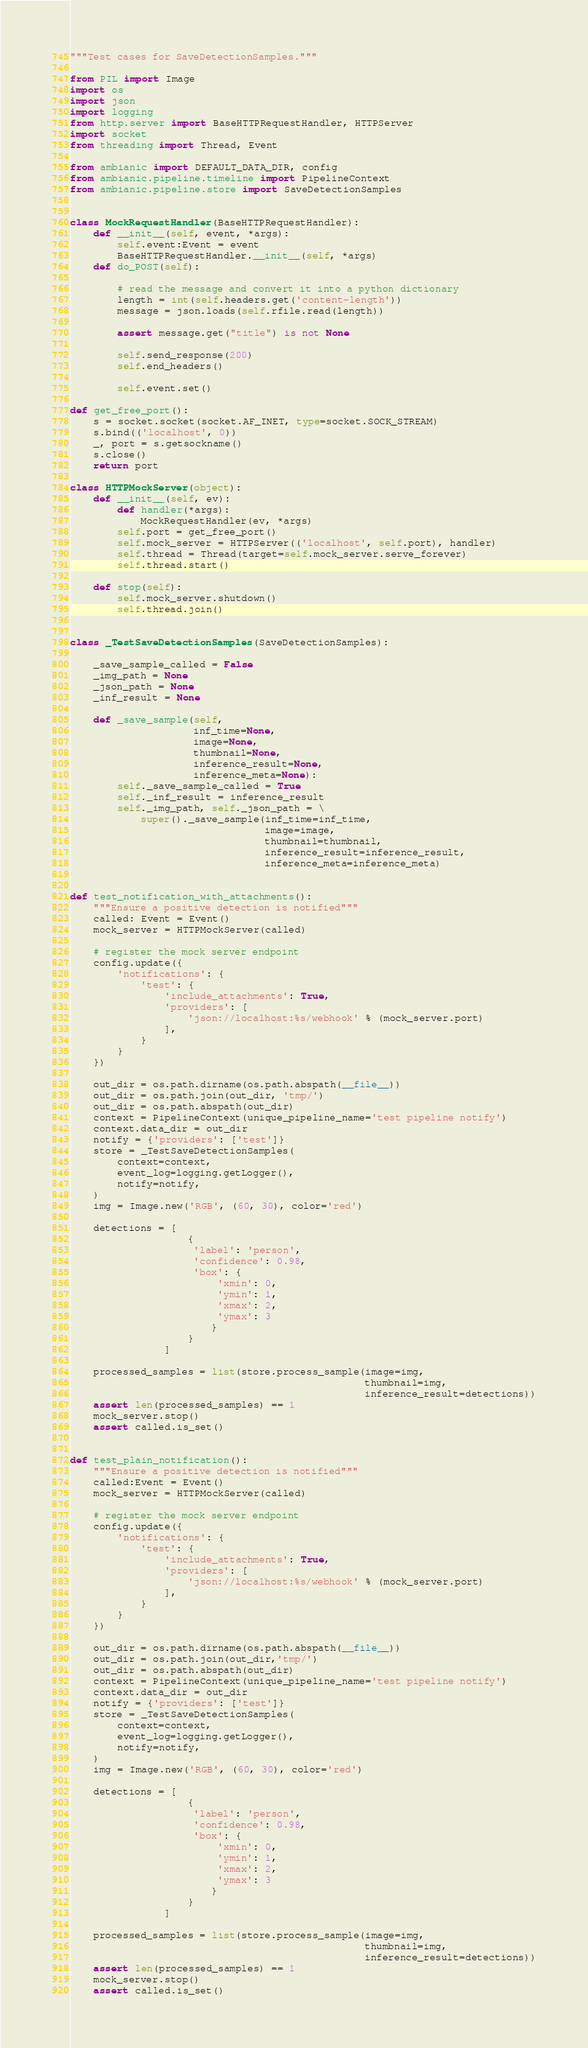<code> <loc_0><loc_0><loc_500><loc_500><_Python_>"""Test cases for SaveDetectionSamples."""

from PIL import Image
import os
import json
import logging
from http.server import BaseHTTPRequestHandler, HTTPServer
import socket
from threading import Thread, Event

from ambianic import DEFAULT_DATA_DIR, config
from ambianic.pipeline.timeline import PipelineContext
from ambianic.pipeline.store import SaveDetectionSamples


class MockRequestHandler(BaseHTTPRequestHandler):
    def __init__(self, event, *args):
        self.event:Event = event
        BaseHTTPRequestHandler.__init__(self, *args)
    def do_POST(self):

        # read the message and convert it into a python dictionary
        length = int(self.headers.get('content-length'))
        message = json.loads(self.rfile.read(length))

        assert message.get("title") is not None

        self.send_response(200)
        self.end_headers()

        self.event.set()

def get_free_port():
    s = socket.socket(socket.AF_INET, type=socket.SOCK_STREAM)
    s.bind(('localhost', 0))
    _, port = s.getsockname()
    s.close()
    return port

class HTTPMockServer(object):
    def __init__(self, ev):
        def handler(*args):
            MockRequestHandler(ev, *args)
        self.port = get_free_port()
        self.mock_server = HTTPServer(('localhost', self.port), handler)
        self.thread = Thread(target=self.mock_server.serve_forever)
        self.thread.start()
    
    def stop(self):
        self.mock_server.shutdown()
        self.thread.join()


class _TestSaveDetectionSamples(SaveDetectionSamples):

    _save_sample_called = False
    _img_path = None
    _json_path = None
    _inf_result = None

    def _save_sample(self,
                     inf_time=None,
                     image=None,
                     thumbnail=None,
                     inference_result=None,
                     inference_meta=None):
        self._save_sample_called = True
        self._inf_result = inference_result
        self._img_path, self._json_path = \
            super()._save_sample(inf_time=inf_time,
                                 image=image,
                                 thumbnail=thumbnail,
                                 inference_result=inference_result,
                                 inference_meta=inference_meta)


def test_notification_with_attachments():
    """Ensure a positive detection is notified"""
    called: Event = Event()
    mock_server = HTTPMockServer(called)

    # register the mock server endpoint
    config.update({
        'notifications': {
            'test': {
                'include_attachments': True,
                'providers': [
                    'json://localhost:%s/webhook' % (mock_server.port)
                ],
            }
        }
    })

    out_dir = os.path.dirname(os.path.abspath(__file__))
    out_dir = os.path.join(out_dir, 'tmp/')
    out_dir = os.path.abspath(out_dir)
    context = PipelineContext(unique_pipeline_name='test pipeline notify')
    context.data_dir = out_dir
    notify = {'providers': ['test']}
    store = _TestSaveDetectionSamples(
        context=context,
        event_log=logging.getLogger(),
        notify=notify,
    )
    img = Image.new('RGB', (60, 30), color='red')

    detections = [
                    {
                     'label': 'person',
                     'confidence': 0.98,
                     'box': {
                         'xmin': 0,
                         'ymin': 1,
                         'xmax': 2,
                         'ymax': 3
                        }
                    }
                ]

    processed_samples = list(store.process_sample(image=img,
                                                  thumbnail=img,
                                                  inference_result=detections))
    assert len(processed_samples) == 1
    mock_server.stop()
    assert called.is_set()


def test_plain_notification():
    """Ensure a positive detection is notified"""
    called:Event = Event()
    mock_server = HTTPMockServer(called)

    # register the mock server endpoint
    config.update({
        'notifications': {
            'test': {
                'include_attachments': True,
                'providers': [
                    'json://localhost:%s/webhook' % (mock_server.port)
                ],
            }
        }
    })

    out_dir = os.path.dirname(os.path.abspath(__file__))
    out_dir = os.path.join(out_dir,'tmp/')
    out_dir = os.path.abspath(out_dir)
    context = PipelineContext(unique_pipeline_name='test pipeline notify')
    context.data_dir = out_dir
    notify = {'providers': ['test']}
    store = _TestSaveDetectionSamples(
        context=context,
        event_log=logging.getLogger(),
        notify=notify,
    )
    img = Image.new('RGB', (60, 30), color='red')

    detections = [
                    {
                     'label': 'person',
                     'confidence': 0.98,
                     'box': {
                         'xmin': 0,
                         'ymin': 1,
                         'xmax': 2,
                         'ymax': 3
                        }
                    }
                ]

    processed_samples = list(store.process_sample(image=img,
                                                  thumbnail=img,
                                                  inference_result=detections))
    assert len(processed_samples) == 1
    mock_server.stop()
    assert called.is_set()
</code> 